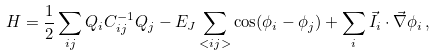<formula> <loc_0><loc_0><loc_500><loc_500>H = \frac { 1 } { 2 } \sum _ { i j } Q _ { i } C ^ { - 1 } _ { i j } Q _ { j } - E _ { J } \sum _ { < i j > } \cos ( \phi _ { i } - \phi _ { j } ) + \sum _ { i } \vec { I } _ { i } \cdot \vec { \nabla } \phi _ { i } \, ,</formula> 